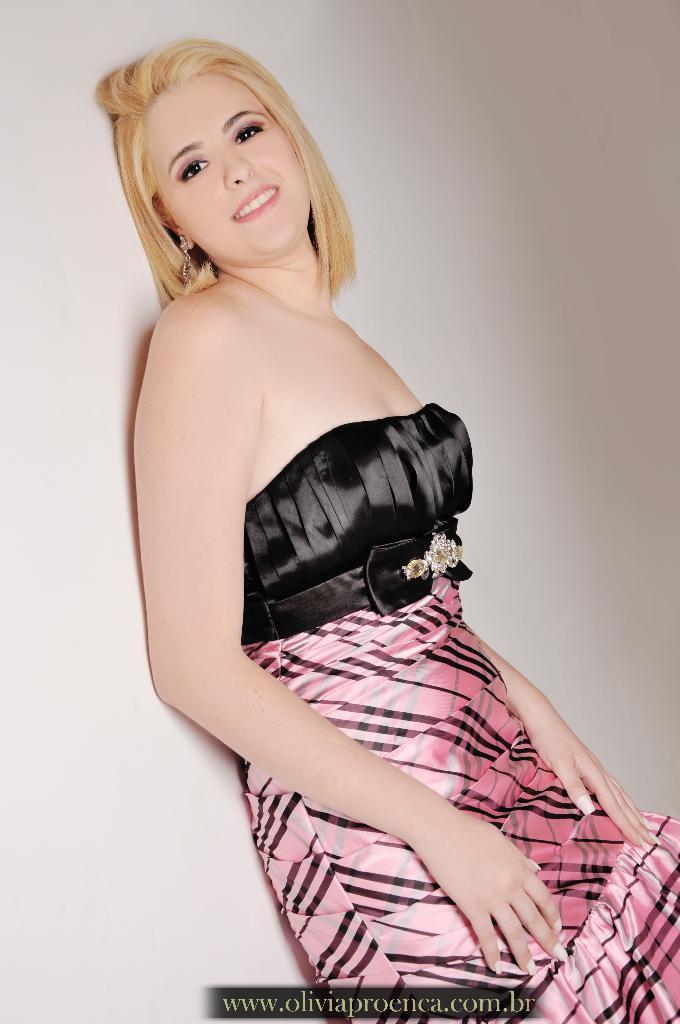Can you describe this image briefly? In the middle of the image, there is a woman in a black and pink color combination dress leaning on a white color wall. At the bottom of the image, there is a watermark. 